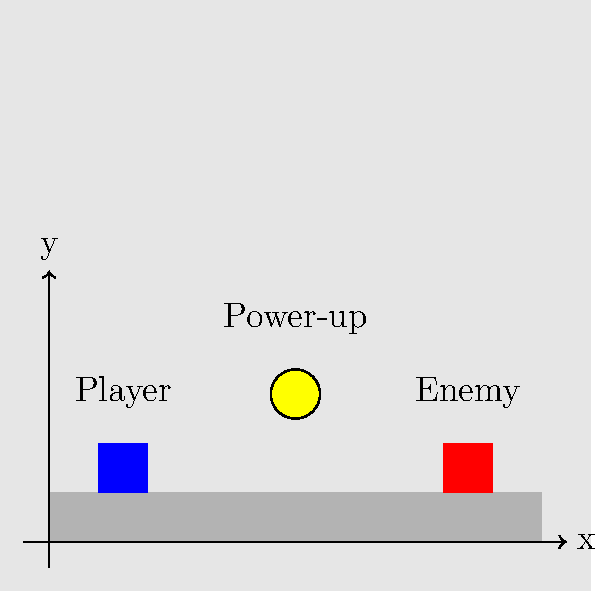In a side-scrolling platformer, a player character, an enemy, and a power-up are positioned as shown in the diagram. The player can jump with an initial vertical velocity of 5 units/second, and gravity acts at -10 units/second². Assuming the player jumps immediately, what is the minimum horizontal velocity (in units/second) the player needs to reach the power-up before falling back to the platform? To solve this problem, we need to follow these steps:

1. Calculate the time it takes for the player to reach the peak of their jump:
   Initial vertical velocity ($v_0$) = 5 units/second
   Acceleration due to gravity ($a$) = -10 units/second²
   Time to reach peak ($t_peak$) = $v_0 / |a| = 5 / 10 = 0.5$ seconds

2. Calculate the maximum height of the jump:
   Maximum height ($h$) = $v_0t - \frac{1}{2}at^2 = 5(0.5) - \frac{1}{2}(10)(0.5)^2 = 1.25$ units

3. Determine the vertical distance to the power-up:
   Power-up height = 3 units
   Platform height = 1 unit
   Vertical distance ($d_v$) = 3 - 1 = 2 units

4. Since the maximum jump height (1.25 units) is less than the power-up height (2 units), the player needs to reach the power-up at the peak of their jump.

5. Calculate the horizontal distance to the power-up:
   Power-up x-position = 5 units
   Player x-position = 1.5 units
   Horizontal distance ($d_h$) = 5 - 1.5 = 3.5 units

6. Calculate the minimum horizontal velocity:
   Horizontal velocity ($v_h$) = $d_h / (2 * t_peak)$ = $3.5 / (2 * 0.5)$ = 3.5 units/second

Therefore, the player needs a minimum horizontal velocity of 3.5 units/second to reach the power-up.
Answer: 3.5 units/second 